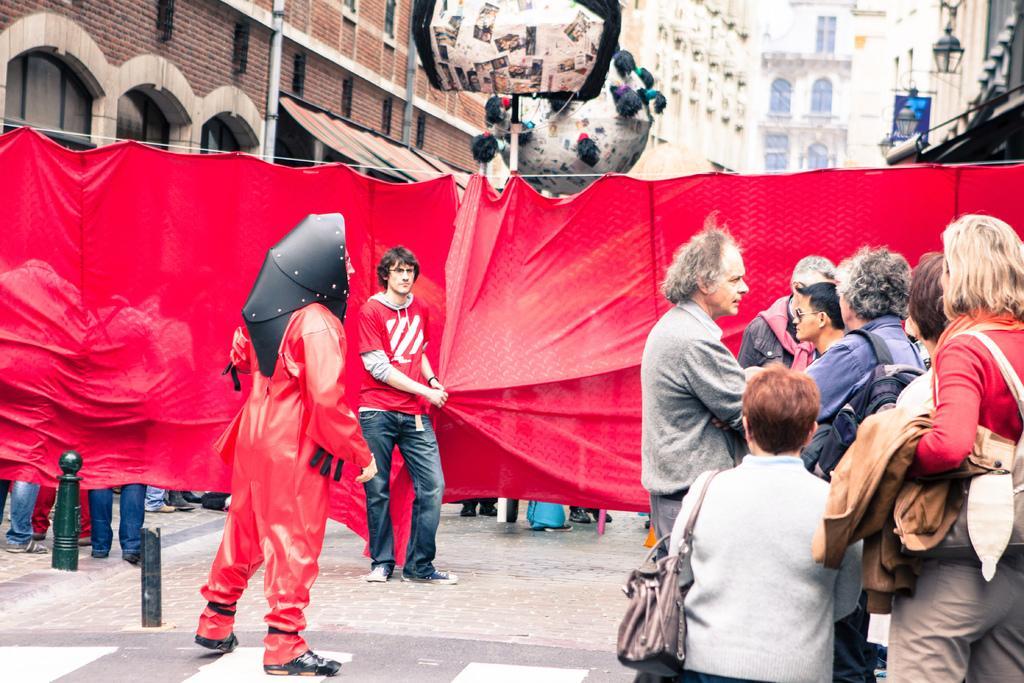Can you describe this image briefly? In this image we can see a man wearing fancy dress and standing on the road. We can also see some persons standing. There is a red color cloth and also an object. In the background we can see the buildings, light and also the blue color hoarding. We can also see the black color rods on the left. 